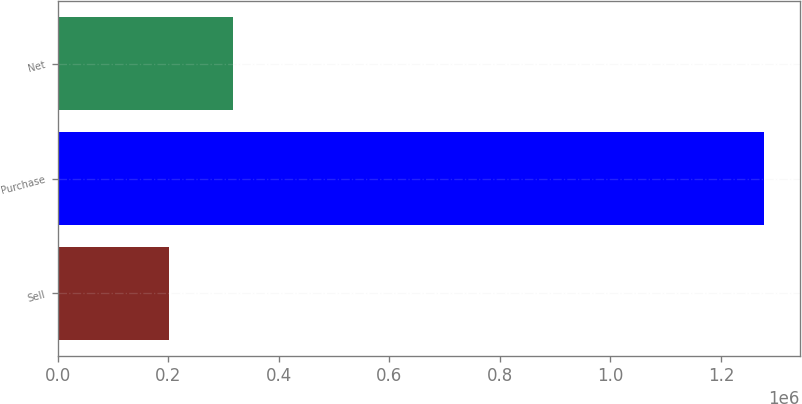Convert chart. <chart><loc_0><loc_0><loc_500><loc_500><bar_chart><fcel>Sell<fcel>Purchase<fcel>Net<nl><fcel>200676<fcel>1.2784e+06<fcel>316987<nl></chart> 